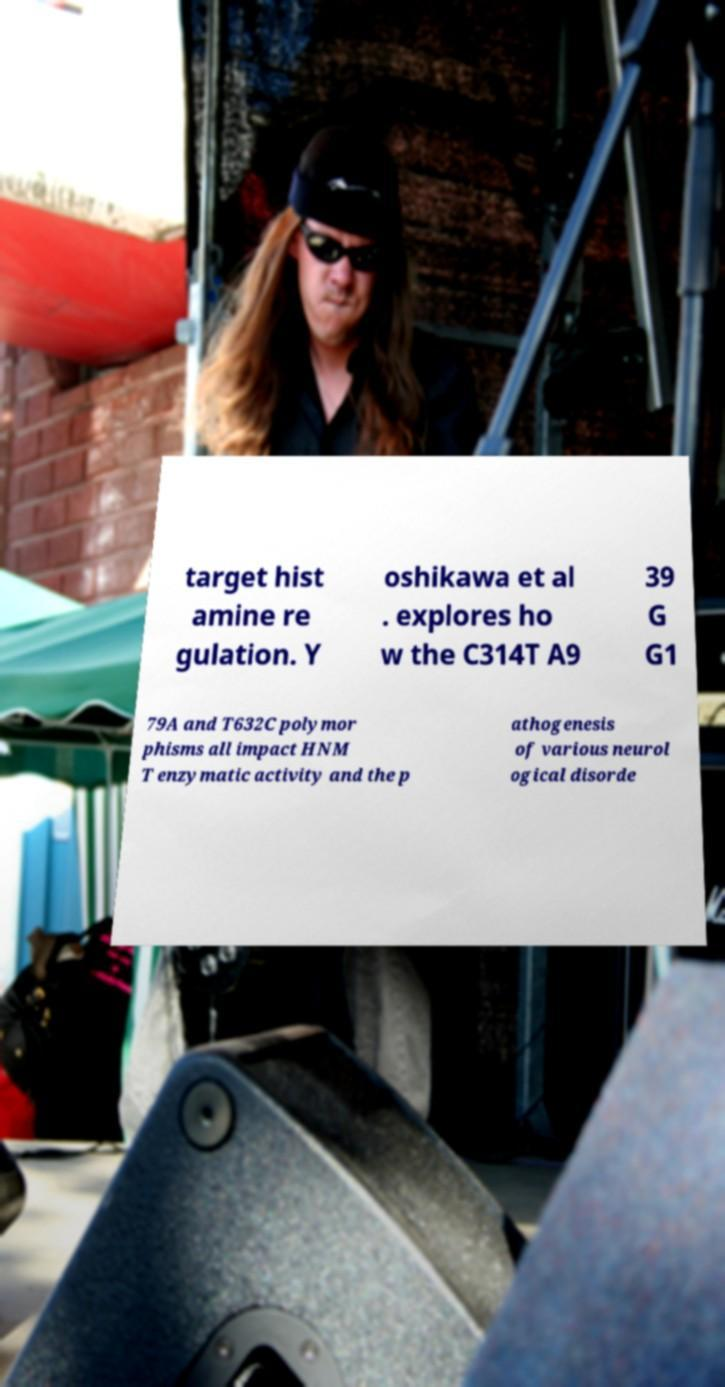Can you read and provide the text displayed in the image?This photo seems to have some interesting text. Can you extract and type it out for me? target hist amine re gulation. Y oshikawa et al . explores ho w the C314T A9 39 G G1 79A and T632C polymor phisms all impact HNM T enzymatic activity and the p athogenesis of various neurol ogical disorde 